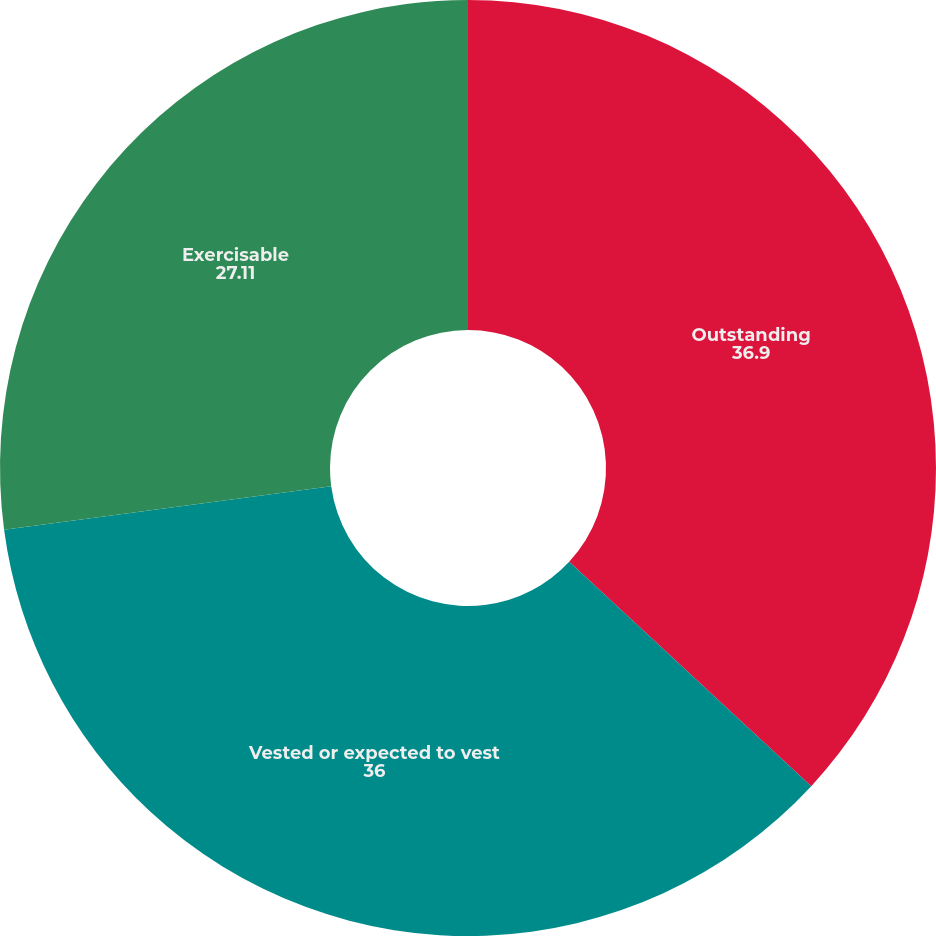Convert chart to OTSL. <chart><loc_0><loc_0><loc_500><loc_500><pie_chart><fcel>Outstanding<fcel>Vested or expected to vest<fcel>Exercisable<nl><fcel>36.9%<fcel>36.0%<fcel>27.11%<nl></chart> 